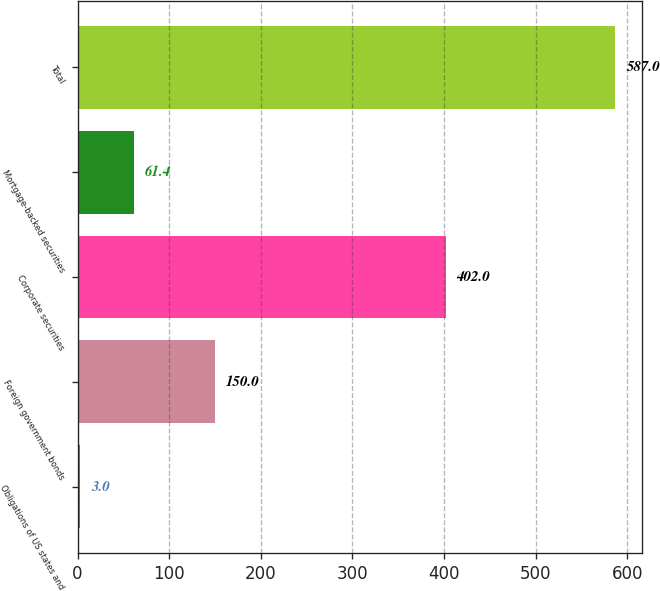Convert chart. <chart><loc_0><loc_0><loc_500><loc_500><bar_chart><fcel>Obligations of US states and<fcel>Foreign government bonds<fcel>Corporate securities<fcel>Mortgage-backed securities<fcel>Total<nl><fcel>3<fcel>150<fcel>402<fcel>61.4<fcel>587<nl></chart> 